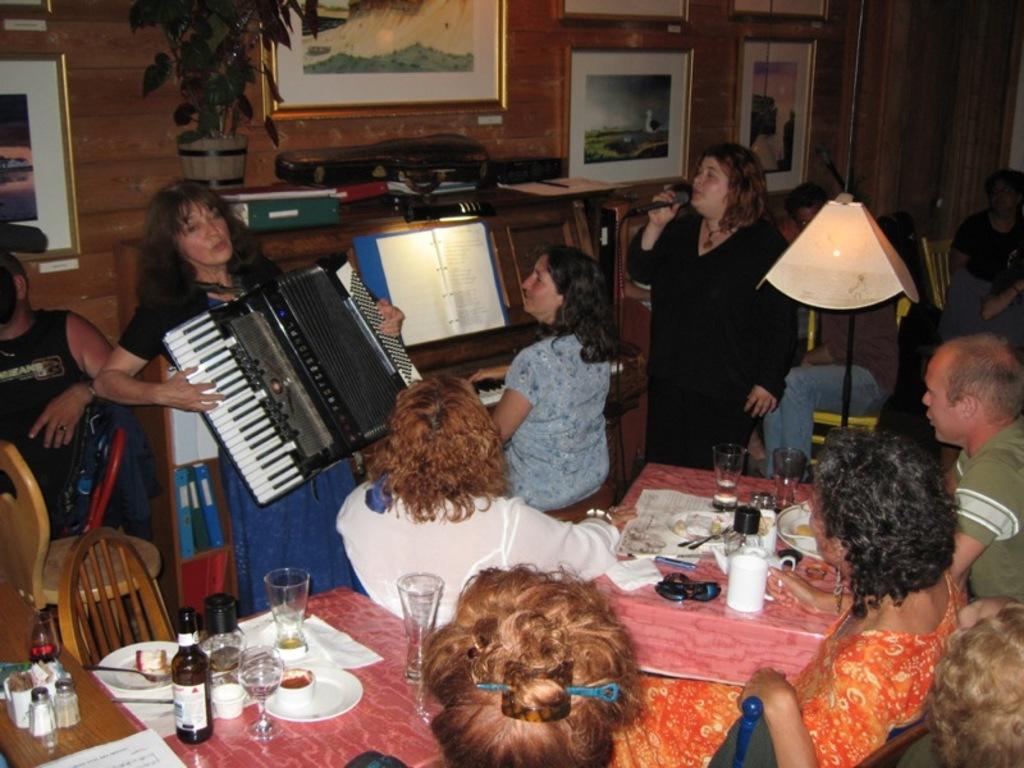Please provide a concise description of this image. This image is taken indoors. In the background there is a wall with many picture frames on it and there is a table with many things and a pot with a plant on it. At the bottom of the image there is a table with many things on it and two women and a man are sitting on the chairs. In the middle of the image a few people are standing and playing music with musical instruments. 